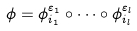<formula> <loc_0><loc_0><loc_500><loc_500>\phi = \phi _ { i _ { 1 } } ^ { \varepsilon _ { 1 } } \circ \cdots \circ \phi _ { i _ { l } } ^ { \varepsilon _ { l } }</formula> 